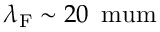Convert formula to latex. <formula><loc_0><loc_0><loc_500><loc_500>\lambda _ { F } \sim 2 0 \, \ m u m</formula> 